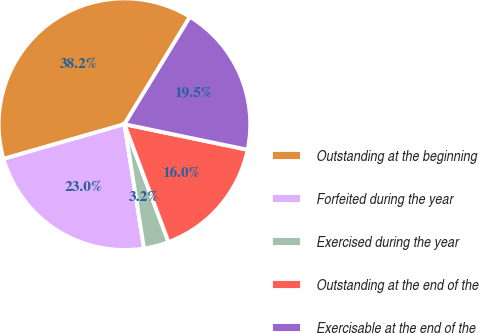Convert chart. <chart><loc_0><loc_0><loc_500><loc_500><pie_chart><fcel>Outstanding at the beginning<fcel>Forfeited during the year<fcel>Exercised during the year<fcel>Outstanding at the end of the<fcel>Exercisable at the end of the<nl><fcel>38.16%<fcel>23.04%<fcel>3.21%<fcel>16.05%<fcel>19.54%<nl></chart> 